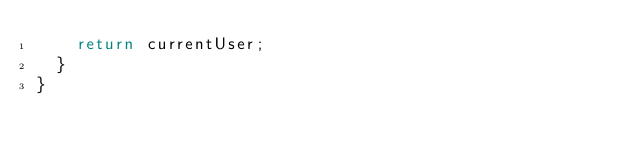<code> <loc_0><loc_0><loc_500><loc_500><_TypeScript_>    return currentUser;
  }
}
</code> 